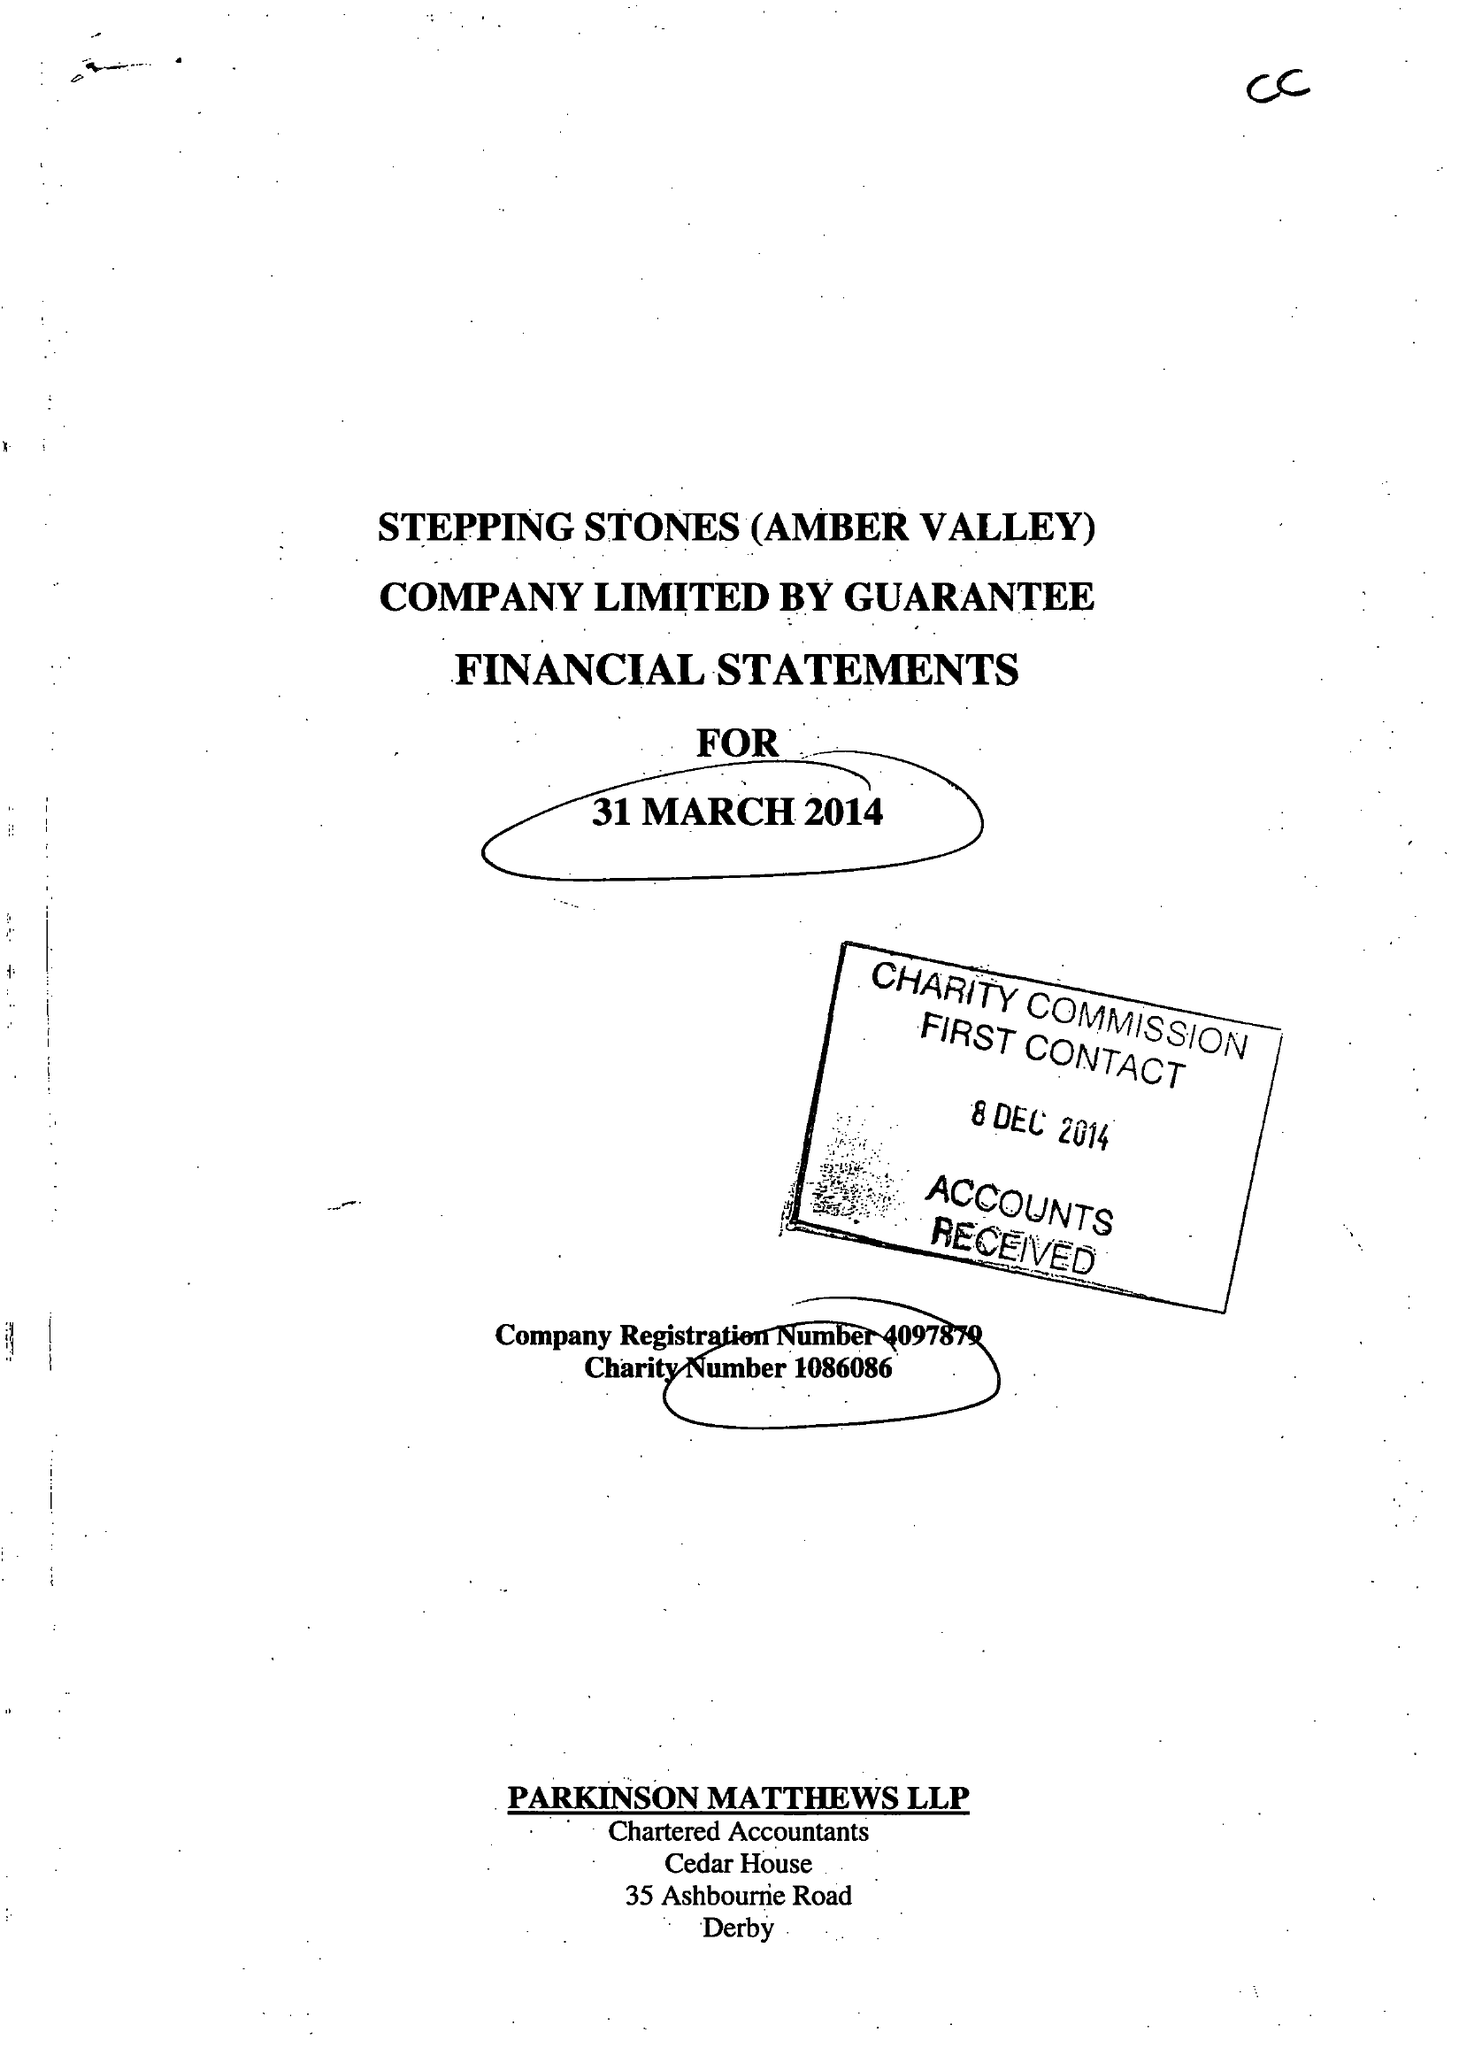What is the value for the spending_annually_in_british_pounds?
Answer the question using a single word or phrase. 130889.00 